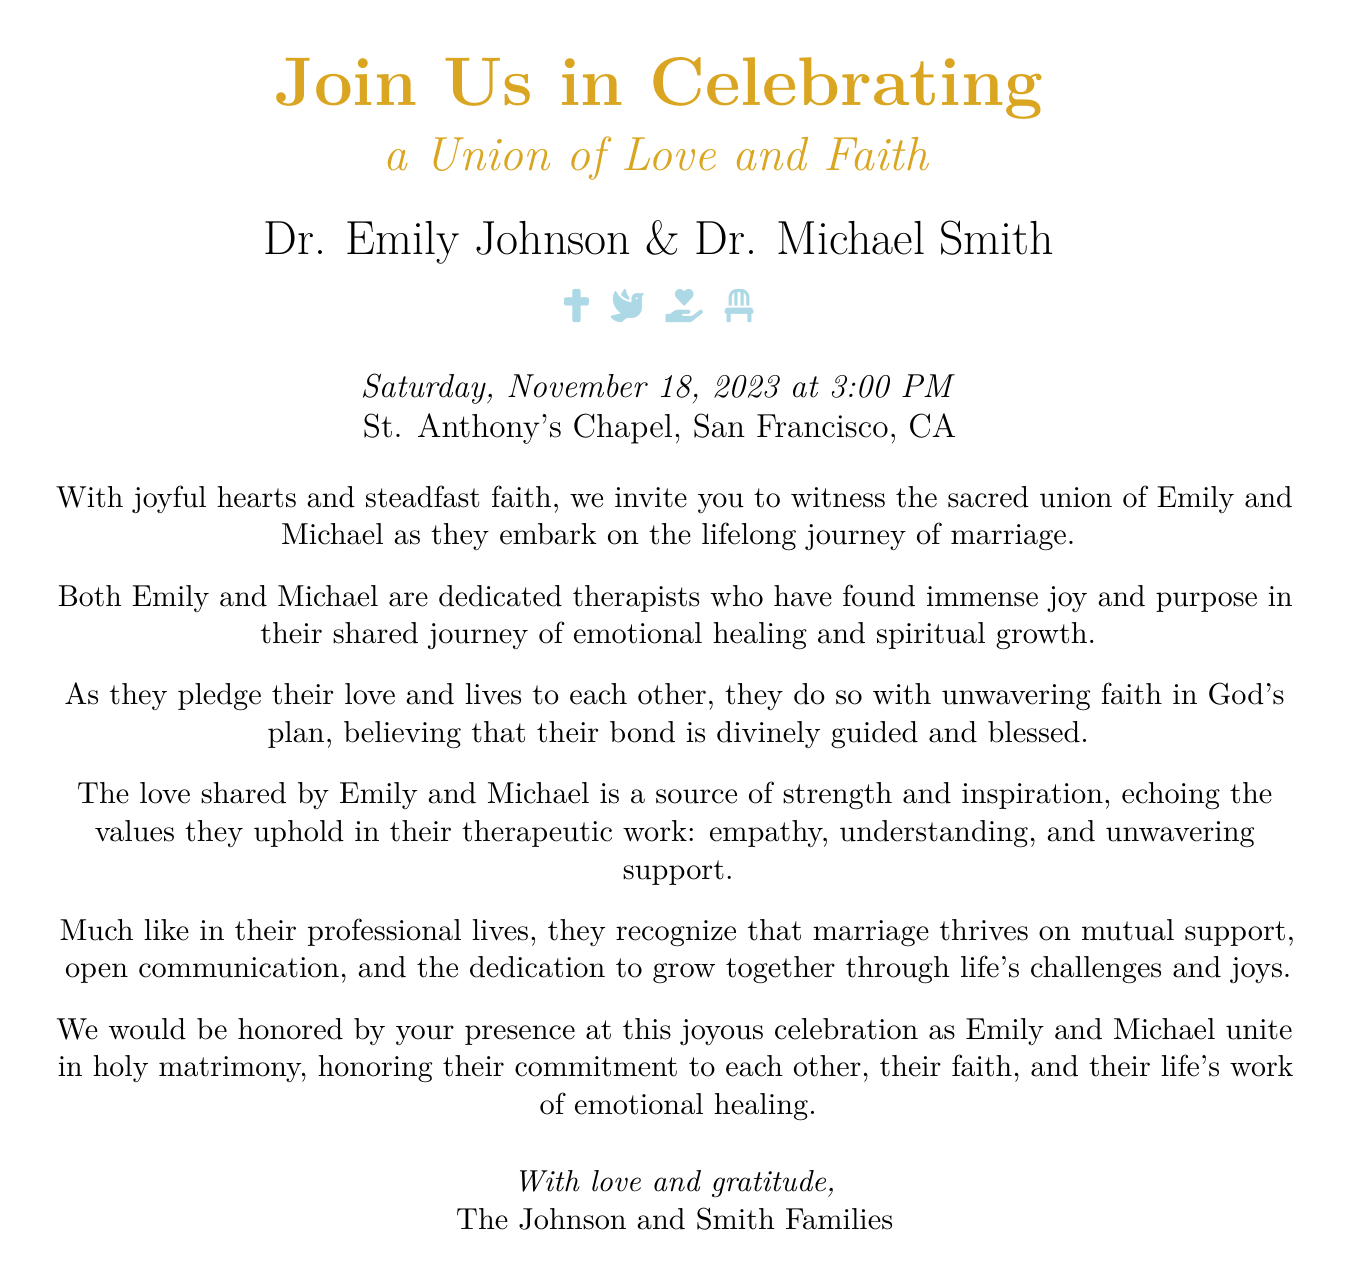What is the date of the wedding? The date is specified in the document as the day of the celebration, which is November 18, 2023.
Answer: November 18, 2023 What are the names of the couple getting married? The document explicitly states the names of the couple as Emily Johnson and Michael Smith.
Answer: Emily Johnson and Michael Smith What is the venue for the wedding? The document identifies the location of the ceremony as St. Anthony's Chapel in San Francisco, CA.
Answer: St. Anthony's Chapel, San Francisco, CA What time is the wedding ceremony scheduled to start? The invitation mentions the time of the ceremony as 3:00 PM.
Answer: 3:00 PM What is the key theme reflected in the wedding invitation? The document emphasizes the theme of love and faith, highlighting the couple's commitment to each other and their shared spirituality.
Answer: Love and faith Why do Emily and Michael want their guests to attend the ceremony? They invite their guests to witness their sacred union and celebrate their commitment to love and faith.
Answer: To witness their sacred union What professions do the couple share? The document notes that both Emily and Michael are dedicated therapists.
Answer: Therapists What values do Emily and Michael uphold in their marriage, according to the invitation? The text indicates that they value empathy, understanding, and unwavering support in both their marriage and professional work.
Answer: Empathy, understanding, and unwavering support 